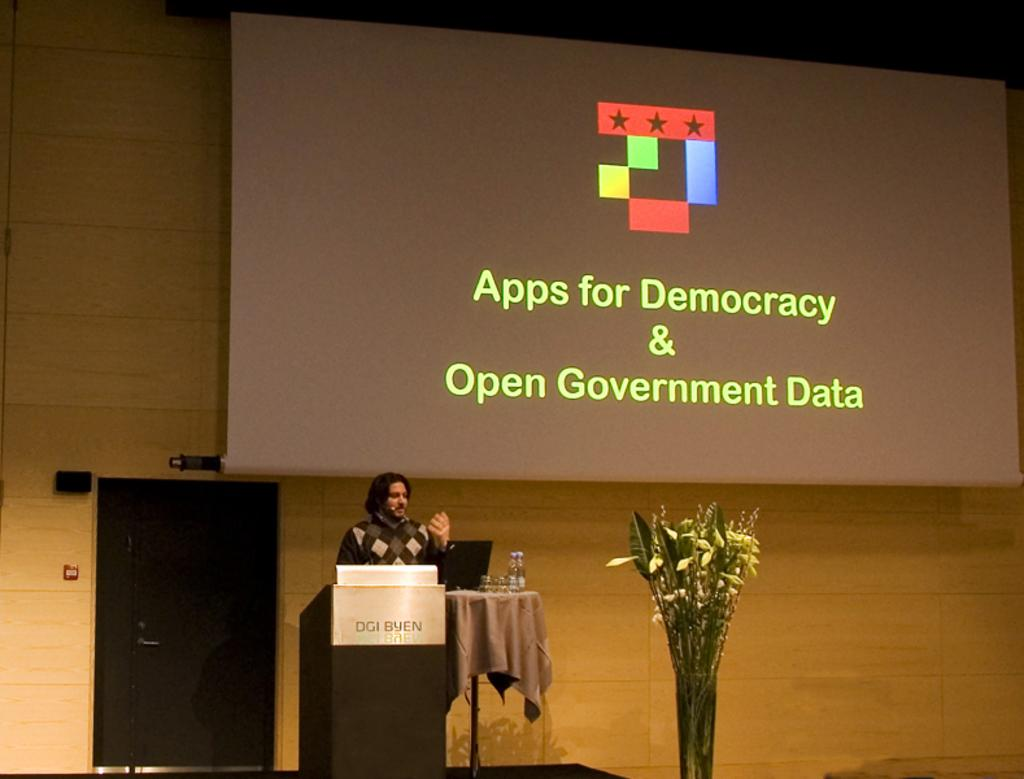What object can be seen holding flowers in the image? There is a flower vase in the image. What type of tableware is present on the table in the image? There are glasses on the table in the image. What other object is present on the table in the image? There is a bottle on the table in the image. What is the person in the image doing? The person is standing near a podium in the image. What can be used for displaying information or visuals in the image? There is a screen in the image. What type of grass is growing near the church in the image? There is no church or grass present in the image. What selection of items is being made by the person at the podium in the image? The image does not show the person making any selections; they are simply standing near the podium. 